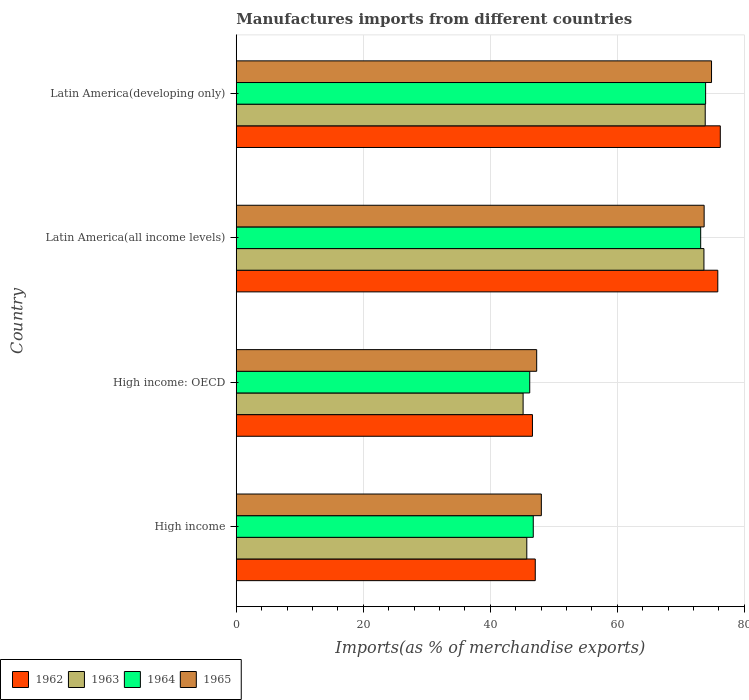How many different coloured bars are there?
Provide a short and direct response. 4. Are the number of bars per tick equal to the number of legend labels?
Your answer should be very brief. Yes. How many bars are there on the 3rd tick from the top?
Ensure brevity in your answer.  4. How many bars are there on the 2nd tick from the bottom?
Keep it short and to the point. 4. What is the label of the 2nd group of bars from the top?
Offer a terse response. Latin America(all income levels). What is the percentage of imports to different countries in 1962 in Latin America(developing only)?
Provide a succinct answer. 76.21. Across all countries, what is the maximum percentage of imports to different countries in 1965?
Provide a succinct answer. 74.83. Across all countries, what is the minimum percentage of imports to different countries in 1963?
Make the answer very short. 45.16. In which country was the percentage of imports to different countries in 1964 maximum?
Offer a very short reply. Latin America(developing only). In which country was the percentage of imports to different countries in 1964 minimum?
Your response must be concise. High income: OECD. What is the total percentage of imports to different countries in 1962 in the graph?
Offer a terse response. 245.75. What is the difference between the percentage of imports to different countries in 1964 in High income and that in Latin America(developing only)?
Make the answer very short. -27.13. What is the difference between the percentage of imports to different countries in 1965 in Latin America(all income levels) and the percentage of imports to different countries in 1964 in High income: OECD?
Your response must be concise. 27.46. What is the average percentage of imports to different countries in 1962 per country?
Your answer should be compact. 61.44. What is the difference between the percentage of imports to different countries in 1964 and percentage of imports to different countries in 1963 in Latin America(developing only)?
Provide a short and direct response. 0.06. In how many countries, is the percentage of imports to different countries in 1963 greater than 64 %?
Ensure brevity in your answer.  2. What is the ratio of the percentage of imports to different countries in 1965 in High income to that in High income: OECD?
Keep it short and to the point. 1.02. What is the difference between the highest and the second highest percentage of imports to different countries in 1963?
Provide a short and direct response. 0.2. What is the difference between the highest and the lowest percentage of imports to different countries in 1963?
Make the answer very short. 28.67. Is it the case that in every country, the sum of the percentage of imports to different countries in 1964 and percentage of imports to different countries in 1963 is greater than the sum of percentage of imports to different countries in 1962 and percentage of imports to different countries in 1965?
Provide a succinct answer. No. What does the 2nd bar from the top in High income: OECD represents?
Your response must be concise. 1964. Is it the case that in every country, the sum of the percentage of imports to different countries in 1962 and percentage of imports to different countries in 1963 is greater than the percentage of imports to different countries in 1965?
Your answer should be compact. Yes. How many bars are there?
Make the answer very short. 16. Are all the bars in the graph horizontal?
Provide a short and direct response. Yes. Are the values on the major ticks of X-axis written in scientific E-notation?
Your answer should be very brief. No. Does the graph contain grids?
Offer a terse response. Yes. How are the legend labels stacked?
Your answer should be very brief. Horizontal. What is the title of the graph?
Provide a short and direct response. Manufactures imports from different countries. Does "2012" appear as one of the legend labels in the graph?
Provide a short and direct response. No. What is the label or title of the X-axis?
Your response must be concise. Imports(as % of merchandise exports). What is the label or title of the Y-axis?
Your answer should be compact. Country. What is the Imports(as % of merchandise exports) in 1962 in High income?
Ensure brevity in your answer.  47.08. What is the Imports(as % of merchandise exports) of 1963 in High income?
Your response must be concise. 45.75. What is the Imports(as % of merchandise exports) of 1964 in High income?
Offer a terse response. 46.77. What is the Imports(as % of merchandise exports) in 1965 in High income?
Your response must be concise. 48.04. What is the Imports(as % of merchandise exports) in 1962 in High income: OECD?
Ensure brevity in your answer.  46.64. What is the Imports(as % of merchandise exports) of 1963 in High income: OECD?
Provide a short and direct response. 45.16. What is the Imports(as % of merchandise exports) of 1964 in High income: OECD?
Your answer should be compact. 46.21. What is the Imports(as % of merchandise exports) of 1965 in High income: OECD?
Give a very brief answer. 47.3. What is the Imports(as % of merchandise exports) in 1962 in Latin America(all income levels)?
Offer a terse response. 75.82. What is the Imports(as % of merchandise exports) of 1963 in Latin America(all income levels)?
Provide a succinct answer. 73.64. What is the Imports(as % of merchandise exports) of 1964 in Latin America(all income levels)?
Make the answer very short. 73.13. What is the Imports(as % of merchandise exports) in 1965 in Latin America(all income levels)?
Your answer should be very brief. 73.67. What is the Imports(as % of merchandise exports) of 1962 in Latin America(developing only)?
Make the answer very short. 76.21. What is the Imports(as % of merchandise exports) in 1963 in Latin America(developing only)?
Provide a succinct answer. 73.84. What is the Imports(as % of merchandise exports) in 1964 in Latin America(developing only)?
Provide a succinct answer. 73.9. What is the Imports(as % of merchandise exports) in 1965 in Latin America(developing only)?
Your response must be concise. 74.83. Across all countries, what is the maximum Imports(as % of merchandise exports) of 1962?
Your answer should be very brief. 76.21. Across all countries, what is the maximum Imports(as % of merchandise exports) of 1963?
Ensure brevity in your answer.  73.84. Across all countries, what is the maximum Imports(as % of merchandise exports) of 1964?
Your response must be concise. 73.9. Across all countries, what is the maximum Imports(as % of merchandise exports) of 1965?
Your response must be concise. 74.83. Across all countries, what is the minimum Imports(as % of merchandise exports) in 1962?
Offer a terse response. 46.64. Across all countries, what is the minimum Imports(as % of merchandise exports) in 1963?
Your response must be concise. 45.16. Across all countries, what is the minimum Imports(as % of merchandise exports) of 1964?
Make the answer very short. 46.21. Across all countries, what is the minimum Imports(as % of merchandise exports) in 1965?
Offer a very short reply. 47.3. What is the total Imports(as % of merchandise exports) of 1962 in the graph?
Offer a terse response. 245.75. What is the total Imports(as % of merchandise exports) of 1963 in the graph?
Give a very brief answer. 238.38. What is the total Imports(as % of merchandise exports) of 1964 in the graph?
Your answer should be very brief. 240. What is the total Imports(as % of merchandise exports) of 1965 in the graph?
Keep it short and to the point. 243.84. What is the difference between the Imports(as % of merchandise exports) in 1962 in High income and that in High income: OECD?
Keep it short and to the point. 0.44. What is the difference between the Imports(as % of merchandise exports) of 1963 in High income and that in High income: OECD?
Ensure brevity in your answer.  0.58. What is the difference between the Imports(as % of merchandise exports) of 1964 in High income and that in High income: OECD?
Your response must be concise. 0.56. What is the difference between the Imports(as % of merchandise exports) in 1965 in High income and that in High income: OECD?
Your response must be concise. 0.73. What is the difference between the Imports(as % of merchandise exports) in 1962 in High income and that in Latin America(all income levels)?
Your answer should be very brief. -28.74. What is the difference between the Imports(as % of merchandise exports) in 1963 in High income and that in Latin America(all income levels)?
Offer a terse response. -27.89. What is the difference between the Imports(as % of merchandise exports) in 1964 in High income and that in Latin America(all income levels)?
Ensure brevity in your answer.  -26.36. What is the difference between the Imports(as % of merchandise exports) of 1965 in High income and that in Latin America(all income levels)?
Offer a very short reply. -25.63. What is the difference between the Imports(as % of merchandise exports) in 1962 in High income and that in Latin America(developing only)?
Keep it short and to the point. -29.13. What is the difference between the Imports(as % of merchandise exports) in 1963 in High income and that in Latin America(developing only)?
Give a very brief answer. -28.09. What is the difference between the Imports(as % of merchandise exports) of 1964 in High income and that in Latin America(developing only)?
Keep it short and to the point. -27.13. What is the difference between the Imports(as % of merchandise exports) of 1965 in High income and that in Latin America(developing only)?
Keep it short and to the point. -26.8. What is the difference between the Imports(as % of merchandise exports) of 1962 in High income: OECD and that in Latin America(all income levels)?
Offer a terse response. -29.18. What is the difference between the Imports(as % of merchandise exports) of 1963 in High income: OECD and that in Latin America(all income levels)?
Give a very brief answer. -28.47. What is the difference between the Imports(as % of merchandise exports) in 1964 in High income: OECD and that in Latin America(all income levels)?
Make the answer very short. -26.92. What is the difference between the Imports(as % of merchandise exports) of 1965 in High income: OECD and that in Latin America(all income levels)?
Offer a terse response. -26.36. What is the difference between the Imports(as % of merchandise exports) of 1962 in High income: OECD and that in Latin America(developing only)?
Ensure brevity in your answer.  -29.58. What is the difference between the Imports(as % of merchandise exports) in 1963 in High income: OECD and that in Latin America(developing only)?
Offer a very short reply. -28.67. What is the difference between the Imports(as % of merchandise exports) in 1964 in High income: OECD and that in Latin America(developing only)?
Give a very brief answer. -27.69. What is the difference between the Imports(as % of merchandise exports) in 1965 in High income: OECD and that in Latin America(developing only)?
Keep it short and to the point. -27.53. What is the difference between the Imports(as % of merchandise exports) in 1962 in Latin America(all income levels) and that in Latin America(developing only)?
Provide a short and direct response. -0.39. What is the difference between the Imports(as % of merchandise exports) in 1963 in Latin America(all income levels) and that in Latin America(developing only)?
Give a very brief answer. -0.2. What is the difference between the Imports(as % of merchandise exports) of 1964 in Latin America(all income levels) and that in Latin America(developing only)?
Provide a short and direct response. -0.77. What is the difference between the Imports(as % of merchandise exports) of 1965 in Latin America(all income levels) and that in Latin America(developing only)?
Offer a terse response. -1.16. What is the difference between the Imports(as % of merchandise exports) of 1962 in High income and the Imports(as % of merchandise exports) of 1963 in High income: OECD?
Ensure brevity in your answer.  1.92. What is the difference between the Imports(as % of merchandise exports) of 1962 in High income and the Imports(as % of merchandise exports) of 1964 in High income: OECD?
Provide a succinct answer. 0.87. What is the difference between the Imports(as % of merchandise exports) of 1962 in High income and the Imports(as % of merchandise exports) of 1965 in High income: OECD?
Your answer should be very brief. -0.22. What is the difference between the Imports(as % of merchandise exports) of 1963 in High income and the Imports(as % of merchandise exports) of 1964 in High income: OECD?
Give a very brief answer. -0.46. What is the difference between the Imports(as % of merchandise exports) of 1963 in High income and the Imports(as % of merchandise exports) of 1965 in High income: OECD?
Provide a short and direct response. -1.56. What is the difference between the Imports(as % of merchandise exports) of 1964 in High income and the Imports(as % of merchandise exports) of 1965 in High income: OECD?
Your answer should be very brief. -0.54. What is the difference between the Imports(as % of merchandise exports) of 1962 in High income and the Imports(as % of merchandise exports) of 1963 in Latin America(all income levels)?
Your answer should be compact. -26.56. What is the difference between the Imports(as % of merchandise exports) of 1962 in High income and the Imports(as % of merchandise exports) of 1964 in Latin America(all income levels)?
Give a very brief answer. -26.05. What is the difference between the Imports(as % of merchandise exports) of 1962 in High income and the Imports(as % of merchandise exports) of 1965 in Latin America(all income levels)?
Your answer should be very brief. -26.59. What is the difference between the Imports(as % of merchandise exports) in 1963 in High income and the Imports(as % of merchandise exports) in 1964 in Latin America(all income levels)?
Your answer should be very brief. -27.38. What is the difference between the Imports(as % of merchandise exports) in 1963 in High income and the Imports(as % of merchandise exports) in 1965 in Latin America(all income levels)?
Your answer should be very brief. -27.92. What is the difference between the Imports(as % of merchandise exports) in 1964 in High income and the Imports(as % of merchandise exports) in 1965 in Latin America(all income levels)?
Keep it short and to the point. -26.9. What is the difference between the Imports(as % of merchandise exports) in 1962 in High income and the Imports(as % of merchandise exports) in 1963 in Latin America(developing only)?
Make the answer very short. -26.76. What is the difference between the Imports(as % of merchandise exports) of 1962 in High income and the Imports(as % of merchandise exports) of 1964 in Latin America(developing only)?
Your answer should be compact. -26.82. What is the difference between the Imports(as % of merchandise exports) of 1962 in High income and the Imports(as % of merchandise exports) of 1965 in Latin America(developing only)?
Your answer should be compact. -27.75. What is the difference between the Imports(as % of merchandise exports) in 1963 in High income and the Imports(as % of merchandise exports) in 1964 in Latin America(developing only)?
Your response must be concise. -28.15. What is the difference between the Imports(as % of merchandise exports) in 1963 in High income and the Imports(as % of merchandise exports) in 1965 in Latin America(developing only)?
Your answer should be very brief. -29.09. What is the difference between the Imports(as % of merchandise exports) in 1964 in High income and the Imports(as % of merchandise exports) in 1965 in Latin America(developing only)?
Provide a short and direct response. -28.07. What is the difference between the Imports(as % of merchandise exports) in 1962 in High income: OECD and the Imports(as % of merchandise exports) in 1964 in Latin America(all income levels)?
Your answer should be very brief. -26.49. What is the difference between the Imports(as % of merchandise exports) of 1962 in High income: OECD and the Imports(as % of merchandise exports) of 1965 in Latin America(all income levels)?
Provide a succinct answer. -27.03. What is the difference between the Imports(as % of merchandise exports) of 1963 in High income: OECD and the Imports(as % of merchandise exports) of 1964 in Latin America(all income levels)?
Provide a succinct answer. -27.96. What is the difference between the Imports(as % of merchandise exports) in 1963 in High income: OECD and the Imports(as % of merchandise exports) in 1965 in Latin America(all income levels)?
Your answer should be compact. -28.5. What is the difference between the Imports(as % of merchandise exports) in 1964 in High income: OECD and the Imports(as % of merchandise exports) in 1965 in Latin America(all income levels)?
Give a very brief answer. -27.46. What is the difference between the Imports(as % of merchandise exports) of 1962 in High income: OECD and the Imports(as % of merchandise exports) of 1963 in Latin America(developing only)?
Your response must be concise. -27.2. What is the difference between the Imports(as % of merchandise exports) of 1962 in High income: OECD and the Imports(as % of merchandise exports) of 1964 in Latin America(developing only)?
Make the answer very short. -27.26. What is the difference between the Imports(as % of merchandise exports) in 1962 in High income: OECD and the Imports(as % of merchandise exports) in 1965 in Latin America(developing only)?
Offer a terse response. -28.2. What is the difference between the Imports(as % of merchandise exports) in 1963 in High income: OECD and the Imports(as % of merchandise exports) in 1964 in Latin America(developing only)?
Your answer should be very brief. -28.74. What is the difference between the Imports(as % of merchandise exports) in 1963 in High income: OECD and the Imports(as % of merchandise exports) in 1965 in Latin America(developing only)?
Offer a very short reply. -29.67. What is the difference between the Imports(as % of merchandise exports) of 1964 in High income: OECD and the Imports(as % of merchandise exports) of 1965 in Latin America(developing only)?
Offer a very short reply. -28.62. What is the difference between the Imports(as % of merchandise exports) in 1962 in Latin America(all income levels) and the Imports(as % of merchandise exports) in 1963 in Latin America(developing only)?
Provide a short and direct response. 1.98. What is the difference between the Imports(as % of merchandise exports) in 1962 in Latin America(all income levels) and the Imports(as % of merchandise exports) in 1964 in Latin America(developing only)?
Provide a succinct answer. 1.92. What is the difference between the Imports(as % of merchandise exports) in 1962 in Latin America(all income levels) and the Imports(as % of merchandise exports) in 1965 in Latin America(developing only)?
Provide a succinct answer. 0.99. What is the difference between the Imports(as % of merchandise exports) of 1963 in Latin America(all income levels) and the Imports(as % of merchandise exports) of 1964 in Latin America(developing only)?
Give a very brief answer. -0.26. What is the difference between the Imports(as % of merchandise exports) in 1963 in Latin America(all income levels) and the Imports(as % of merchandise exports) in 1965 in Latin America(developing only)?
Ensure brevity in your answer.  -1.2. What is the difference between the Imports(as % of merchandise exports) of 1964 in Latin America(all income levels) and the Imports(as % of merchandise exports) of 1965 in Latin America(developing only)?
Your response must be concise. -1.71. What is the average Imports(as % of merchandise exports) of 1962 per country?
Keep it short and to the point. 61.44. What is the average Imports(as % of merchandise exports) in 1963 per country?
Your answer should be very brief. 59.6. What is the average Imports(as % of merchandise exports) of 1964 per country?
Offer a very short reply. 60. What is the average Imports(as % of merchandise exports) of 1965 per country?
Give a very brief answer. 60.96. What is the difference between the Imports(as % of merchandise exports) of 1962 and Imports(as % of merchandise exports) of 1963 in High income?
Provide a short and direct response. 1.33. What is the difference between the Imports(as % of merchandise exports) of 1962 and Imports(as % of merchandise exports) of 1964 in High income?
Offer a very short reply. 0.31. What is the difference between the Imports(as % of merchandise exports) in 1962 and Imports(as % of merchandise exports) in 1965 in High income?
Provide a short and direct response. -0.96. What is the difference between the Imports(as % of merchandise exports) in 1963 and Imports(as % of merchandise exports) in 1964 in High income?
Provide a succinct answer. -1.02. What is the difference between the Imports(as % of merchandise exports) of 1963 and Imports(as % of merchandise exports) of 1965 in High income?
Offer a very short reply. -2.29. What is the difference between the Imports(as % of merchandise exports) of 1964 and Imports(as % of merchandise exports) of 1965 in High income?
Offer a very short reply. -1.27. What is the difference between the Imports(as % of merchandise exports) of 1962 and Imports(as % of merchandise exports) of 1963 in High income: OECD?
Provide a succinct answer. 1.47. What is the difference between the Imports(as % of merchandise exports) in 1962 and Imports(as % of merchandise exports) in 1964 in High income: OECD?
Keep it short and to the point. 0.43. What is the difference between the Imports(as % of merchandise exports) of 1962 and Imports(as % of merchandise exports) of 1965 in High income: OECD?
Your answer should be very brief. -0.67. What is the difference between the Imports(as % of merchandise exports) of 1963 and Imports(as % of merchandise exports) of 1964 in High income: OECD?
Ensure brevity in your answer.  -1.04. What is the difference between the Imports(as % of merchandise exports) in 1963 and Imports(as % of merchandise exports) in 1965 in High income: OECD?
Provide a short and direct response. -2.14. What is the difference between the Imports(as % of merchandise exports) in 1964 and Imports(as % of merchandise exports) in 1965 in High income: OECD?
Provide a succinct answer. -1.1. What is the difference between the Imports(as % of merchandise exports) in 1962 and Imports(as % of merchandise exports) in 1963 in Latin America(all income levels)?
Give a very brief answer. 2.18. What is the difference between the Imports(as % of merchandise exports) of 1962 and Imports(as % of merchandise exports) of 1964 in Latin America(all income levels)?
Make the answer very short. 2.69. What is the difference between the Imports(as % of merchandise exports) in 1962 and Imports(as % of merchandise exports) in 1965 in Latin America(all income levels)?
Your response must be concise. 2.15. What is the difference between the Imports(as % of merchandise exports) in 1963 and Imports(as % of merchandise exports) in 1964 in Latin America(all income levels)?
Give a very brief answer. 0.51. What is the difference between the Imports(as % of merchandise exports) in 1963 and Imports(as % of merchandise exports) in 1965 in Latin America(all income levels)?
Provide a succinct answer. -0.03. What is the difference between the Imports(as % of merchandise exports) of 1964 and Imports(as % of merchandise exports) of 1965 in Latin America(all income levels)?
Make the answer very short. -0.54. What is the difference between the Imports(as % of merchandise exports) in 1962 and Imports(as % of merchandise exports) in 1963 in Latin America(developing only)?
Provide a short and direct response. 2.37. What is the difference between the Imports(as % of merchandise exports) of 1962 and Imports(as % of merchandise exports) of 1964 in Latin America(developing only)?
Offer a very short reply. 2.31. What is the difference between the Imports(as % of merchandise exports) in 1962 and Imports(as % of merchandise exports) in 1965 in Latin America(developing only)?
Provide a short and direct response. 1.38. What is the difference between the Imports(as % of merchandise exports) in 1963 and Imports(as % of merchandise exports) in 1964 in Latin America(developing only)?
Offer a terse response. -0.06. What is the difference between the Imports(as % of merchandise exports) of 1963 and Imports(as % of merchandise exports) of 1965 in Latin America(developing only)?
Offer a very short reply. -0.99. What is the difference between the Imports(as % of merchandise exports) of 1964 and Imports(as % of merchandise exports) of 1965 in Latin America(developing only)?
Make the answer very short. -0.93. What is the ratio of the Imports(as % of merchandise exports) in 1962 in High income to that in High income: OECD?
Keep it short and to the point. 1.01. What is the ratio of the Imports(as % of merchandise exports) of 1963 in High income to that in High income: OECD?
Ensure brevity in your answer.  1.01. What is the ratio of the Imports(as % of merchandise exports) in 1964 in High income to that in High income: OECD?
Make the answer very short. 1.01. What is the ratio of the Imports(as % of merchandise exports) in 1965 in High income to that in High income: OECD?
Provide a short and direct response. 1.02. What is the ratio of the Imports(as % of merchandise exports) in 1962 in High income to that in Latin America(all income levels)?
Give a very brief answer. 0.62. What is the ratio of the Imports(as % of merchandise exports) in 1963 in High income to that in Latin America(all income levels)?
Give a very brief answer. 0.62. What is the ratio of the Imports(as % of merchandise exports) of 1964 in High income to that in Latin America(all income levels)?
Give a very brief answer. 0.64. What is the ratio of the Imports(as % of merchandise exports) of 1965 in High income to that in Latin America(all income levels)?
Provide a short and direct response. 0.65. What is the ratio of the Imports(as % of merchandise exports) of 1962 in High income to that in Latin America(developing only)?
Make the answer very short. 0.62. What is the ratio of the Imports(as % of merchandise exports) of 1963 in High income to that in Latin America(developing only)?
Your response must be concise. 0.62. What is the ratio of the Imports(as % of merchandise exports) in 1964 in High income to that in Latin America(developing only)?
Make the answer very short. 0.63. What is the ratio of the Imports(as % of merchandise exports) in 1965 in High income to that in Latin America(developing only)?
Your answer should be compact. 0.64. What is the ratio of the Imports(as % of merchandise exports) of 1962 in High income: OECD to that in Latin America(all income levels)?
Ensure brevity in your answer.  0.62. What is the ratio of the Imports(as % of merchandise exports) in 1963 in High income: OECD to that in Latin America(all income levels)?
Your response must be concise. 0.61. What is the ratio of the Imports(as % of merchandise exports) in 1964 in High income: OECD to that in Latin America(all income levels)?
Your response must be concise. 0.63. What is the ratio of the Imports(as % of merchandise exports) of 1965 in High income: OECD to that in Latin America(all income levels)?
Offer a very short reply. 0.64. What is the ratio of the Imports(as % of merchandise exports) of 1962 in High income: OECD to that in Latin America(developing only)?
Your answer should be very brief. 0.61. What is the ratio of the Imports(as % of merchandise exports) in 1963 in High income: OECD to that in Latin America(developing only)?
Your answer should be very brief. 0.61. What is the ratio of the Imports(as % of merchandise exports) in 1964 in High income: OECD to that in Latin America(developing only)?
Your answer should be compact. 0.63. What is the ratio of the Imports(as % of merchandise exports) in 1965 in High income: OECD to that in Latin America(developing only)?
Offer a terse response. 0.63. What is the ratio of the Imports(as % of merchandise exports) of 1962 in Latin America(all income levels) to that in Latin America(developing only)?
Your answer should be compact. 0.99. What is the ratio of the Imports(as % of merchandise exports) in 1964 in Latin America(all income levels) to that in Latin America(developing only)?
Ensure brevity in your answer.  0.99. What is the ratio of the Imports(as % of merchandise exports) in 1965 in Latin America(all income levels) to that in Latin America(developing only)?
Keep it short and to the point. 0.98. What is the difference between the highest and the second highest Imports(as % of merchandise exports) of 1962?
Ensure brevity in your answer.  0.39. What is the difference between the highest and the second highest Imports(as % of merchandise exports) in 1963?
Make the answer very short. 0.2. What is the difference between the highest and the second highest Imports(as % of merchandise exports) of 1964?
Your answer should be very brief. 0.77. What is the difference between the highest and the second highest Imports(as % of merchandise exports) of 1965?
Provide a short and direct response. 1.16. What is the difference between the highest and the lowest Imports(as % of merchandise exports) in 1962?
Your answer should be compact. 29.58. What is the difference between the highest and the lowest Imports(as % of merchandise exports) in 1963?
Your answer should be compact. 28.67. What is the difference between the highest and the lowest Imports(as % of merchandise exports) in 1964?
Provide a short and direct response. 27.69. What is the difference between the highest and the lowest Imports(as % of merchandise exports) in 1965?
Your answer should be very brief. 27.53. 